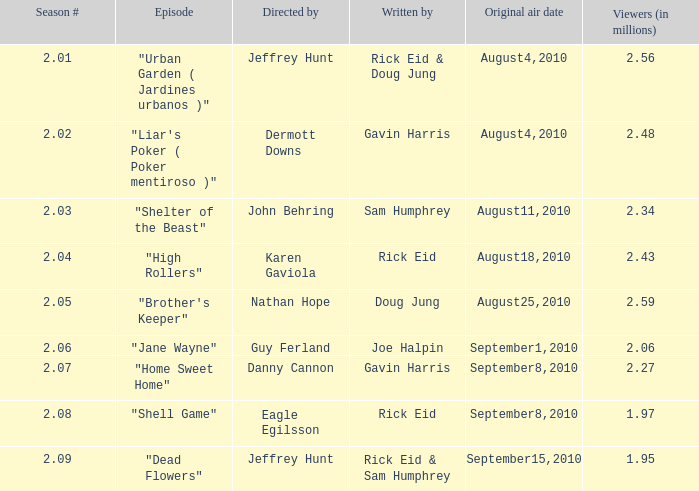Can you identify the author of the episode from season 2.08? Rick Eid. 